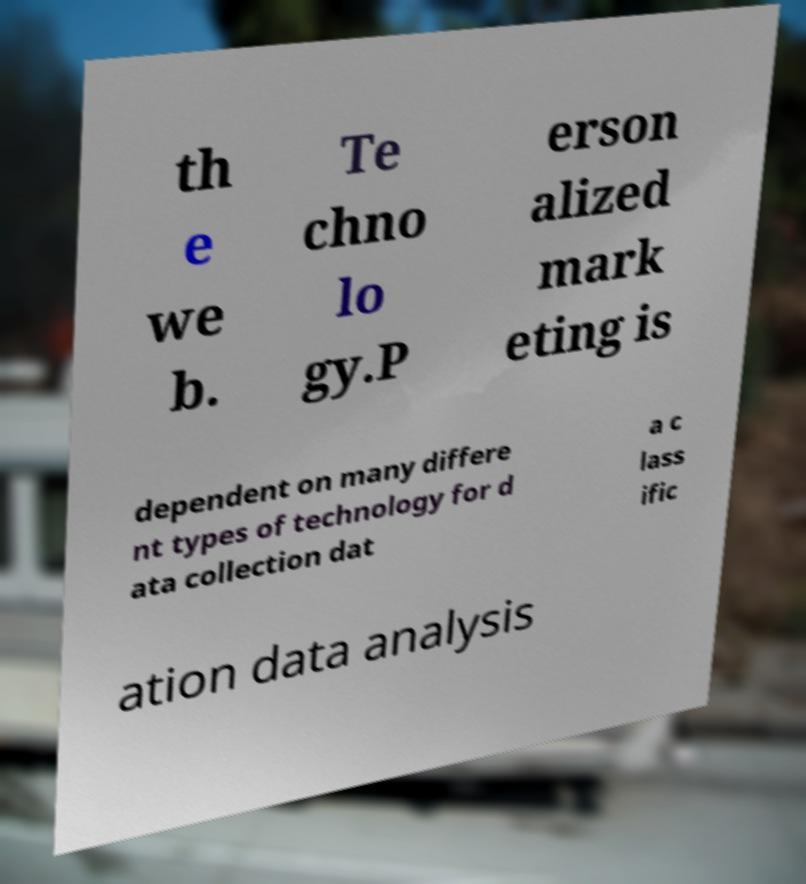Can you read and provide the text displayed in the image?This photo seems to have some interesting text. Can you extract and type it out for me? th e we b. Te chno lo gy.P erson alized mark eting is dependent on many differe nt types of technology for d ata collection dat a c lass ific ation data analysis 